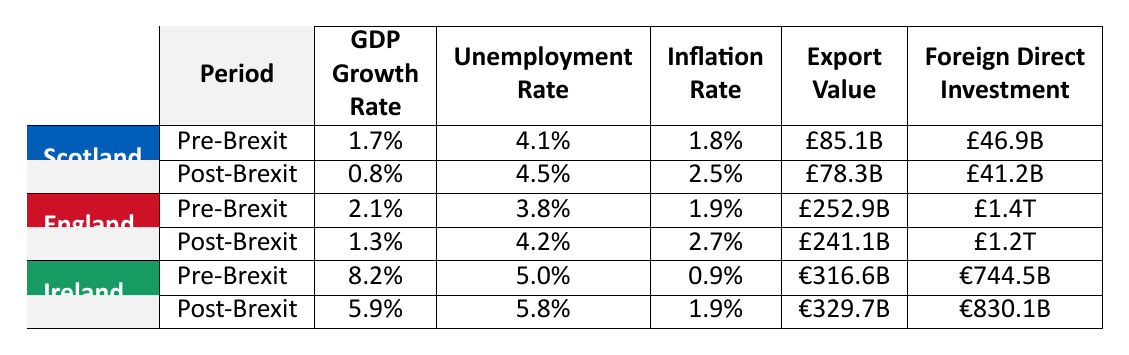What is the GDP growth rate for Scotland post-Brexit? The table shows that the GDP growth rate for Scotland post-Brexit is 0.8%.
Answer: 0.8% What was the unemployment rate in England pre-Brexit? According to the table, the unemployment rate in England pre-Brexit is 3.8%.
Answer: 3.8% What is the difference in the export value of Ireland from pre-Brexit to post-Brexit? The export value for Ireland pre-Brexit is €316.6 billion, and post-Brexit it is €329.7 billion. The difference is €329.7 billion - €316.6 billion = €13.1 billion.
Answer: €13.1 billion Did the inflation rate increase for Scotland after Brexit? The inflation rate for Scotland pre-Brexit was 1.8%, and post-Brexit it increased to 2.5%. Thus, the inflation rate did increase after Brexit.
Answer: Yes What is the average unemployment rate for England pre- and post-Brexit? The unemployment rates for England are 3.8% pre-Brexit and 4.2% post-Brexit. To find the average, we sum the values: (3.8% + 4.2%) / 2 = 4.0%.
Answer: 4.0% Which country had the highest GDP growth rate pre-Brexit? In the table, it shows that Ireland had the highest GDP growth rate pre-Brexit at 8.2%.
Answer: Ireland What is the total foreign direct investment value for Scotland and Ireland pre-Brexit? The foreign direct investment for Scotland pre-Brexit is £46.9 billion and for Ireland it is €744.5 billion. First, we need to convert currencies, assuming the conversion is not required for this total; hence, totaling gives £46.9 billion + €744.5 billion. Since they are in different currencies, we capture each value separately.
Answer: £46.9 billion and €744.5 billion How much did Scotland's foreign direct investment decrease from pre-Brexit to post-Brexit? Scotland's foreign direct investment decreased from £46.9 billion to £41.2 billion. The decrease is £46.9 billion - £41.2 billion = £5.7 billion.
Answer: £5.7 billion Is the inflation rate in England higher post-Brexit compared to pre-Brexit? The inflation rate in England pre-Brexit is 1.9%, while post-Brexit it is 2.7%. Since 2.7% is greater than 1.9%, the inflation rate is indeed higher post-Brexit.
Answer: Yes What was the change in export value for England from pre-Brexit to post-Brexit? The export value for England pre-Brexit is £252.9 billion, and post-Brexit it is £241.1 billion. The change is £241.1 billion - £252.9 billion = -£11.8 billion, indicating a decrease.
Answer: -£11.8 billion 